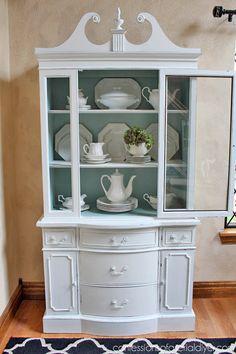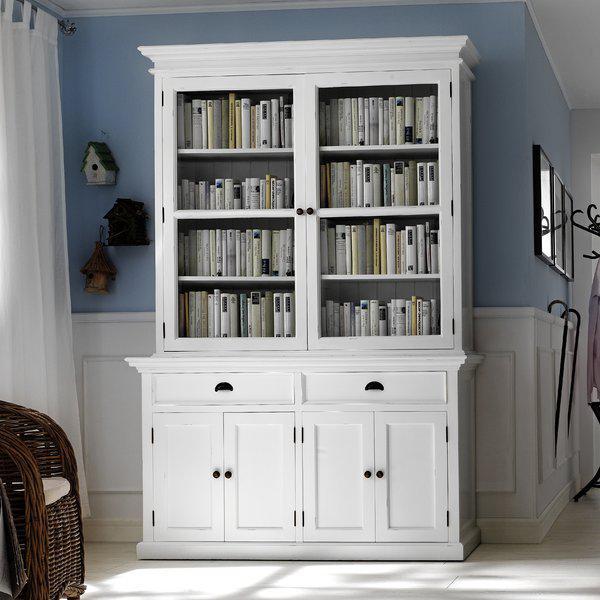The first image is the image on the left, the second image is the image on the right. Given the left and right images, does the statement "There are two freestanding cabinets containing dishes." hold true? Answer yes or no. No. The first image is the image on the left, the second image is the image on the right. Given the left and right images, does the statement "One cabinet is white with a pale blue interior and sculpted, non-flat top, and sits flush to the floor." hold true? Answer yes or no. Yes. 